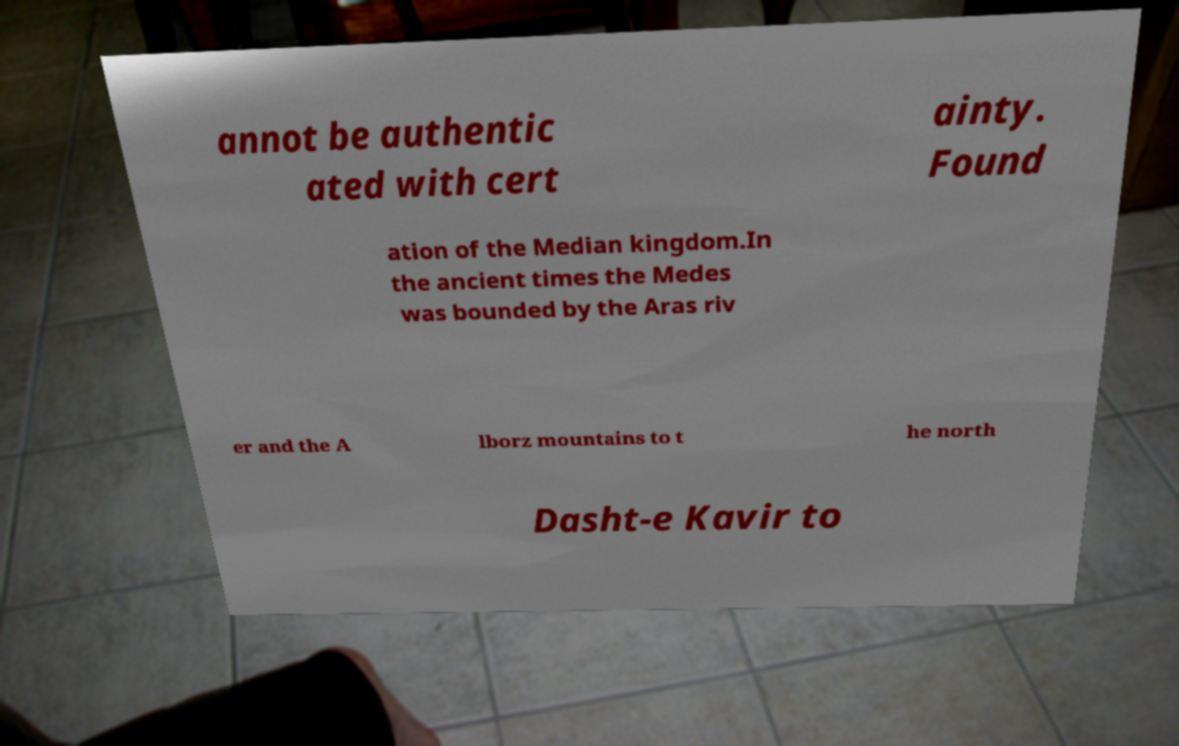There's text embedded in this image that I need extracted. Can you transcribe it verbatim? annot be authentic ated with cert ainty. Found ation of the Median kingdom.In the ancient times the Medes was bounded by the Aras riv er and the A lborz mountains to t he north Dasht-e Kavir to 